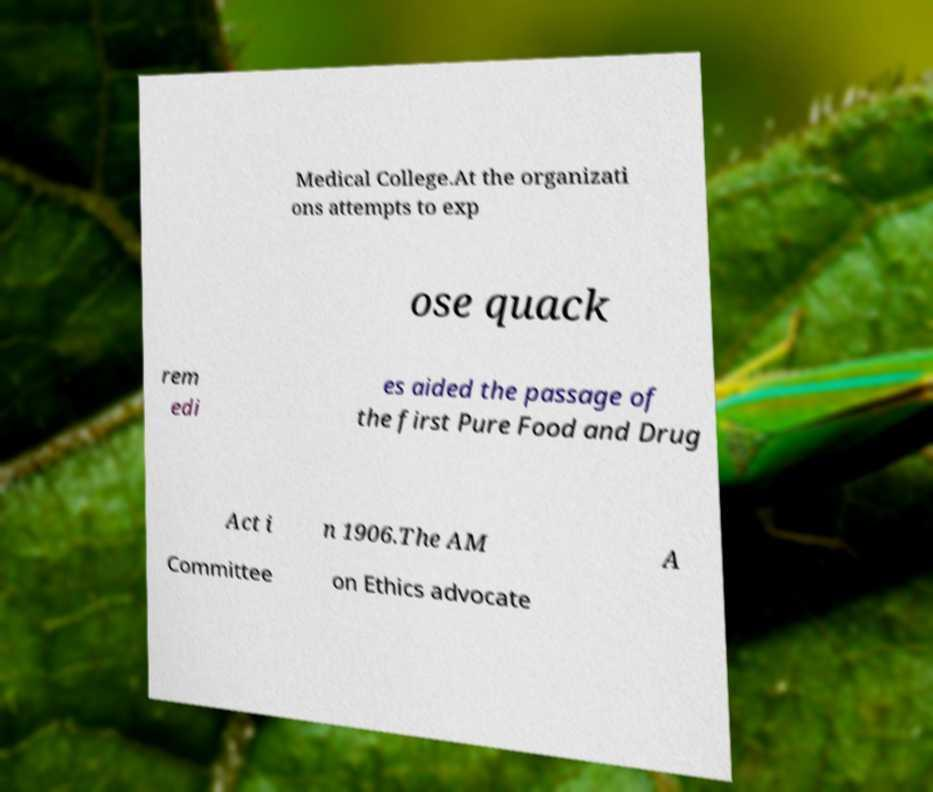Can you read and provide the text displayed in the image?This photo seems to have some interesting text. Can you extract and type it out for me? Medical College.At the organizati ons attempts to exp ose quack rem edi es aided the passage of the first Pure Food and Drug Act i n 1906.The AM A Committee on Ethics advocate 